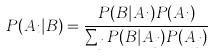Convert formula to latex. <formula><loc_0><loc_0><loc_500><loc_500>P ( A _ { i } | B ) = { \frac { P ( B | A _ { i } ) P ( A _ { i } ) } { \sum _ { j } { P ( B | A _ { j } ) P ( A _ { j } ) } } }</formula> 